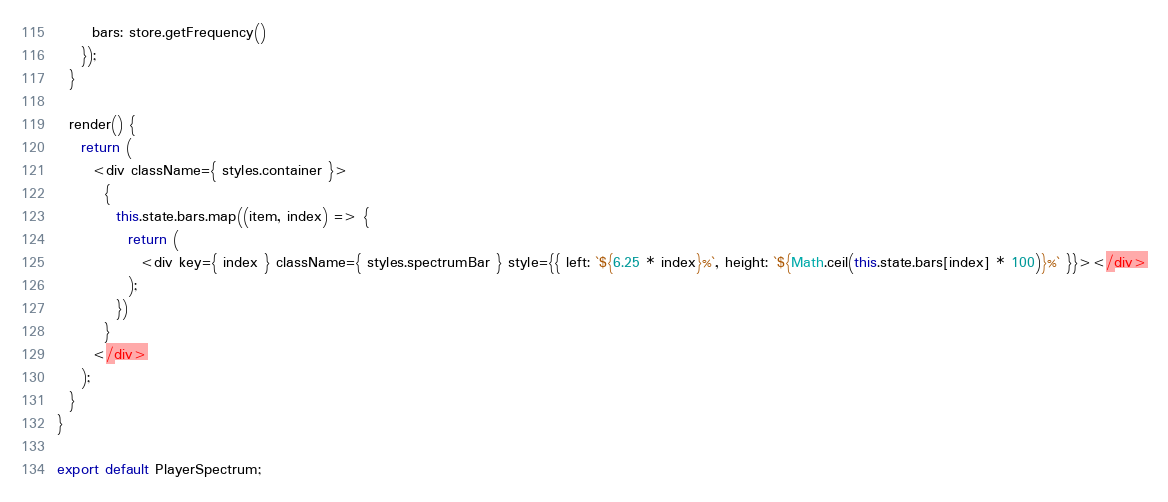<code> <loc_0><loc_0><loc_500><loc_500><_JavaScript_>      bars: store.getFrequency()
    });
  }

  render() {
    return (
      <div className={ styles.container }>
        {
          this.state.bars.map((item, index) => {
            return (
              <div key={ index } className={ styles.spectrumBar } style={{ left: `${6.25 * index}%`, height: `${Math.ceil(this.state.bars[index] * 100)}%` }}></div>
            );
          })
        }
      </div>
    );
  }
}

export default PlayerSpectrum;
</code> 